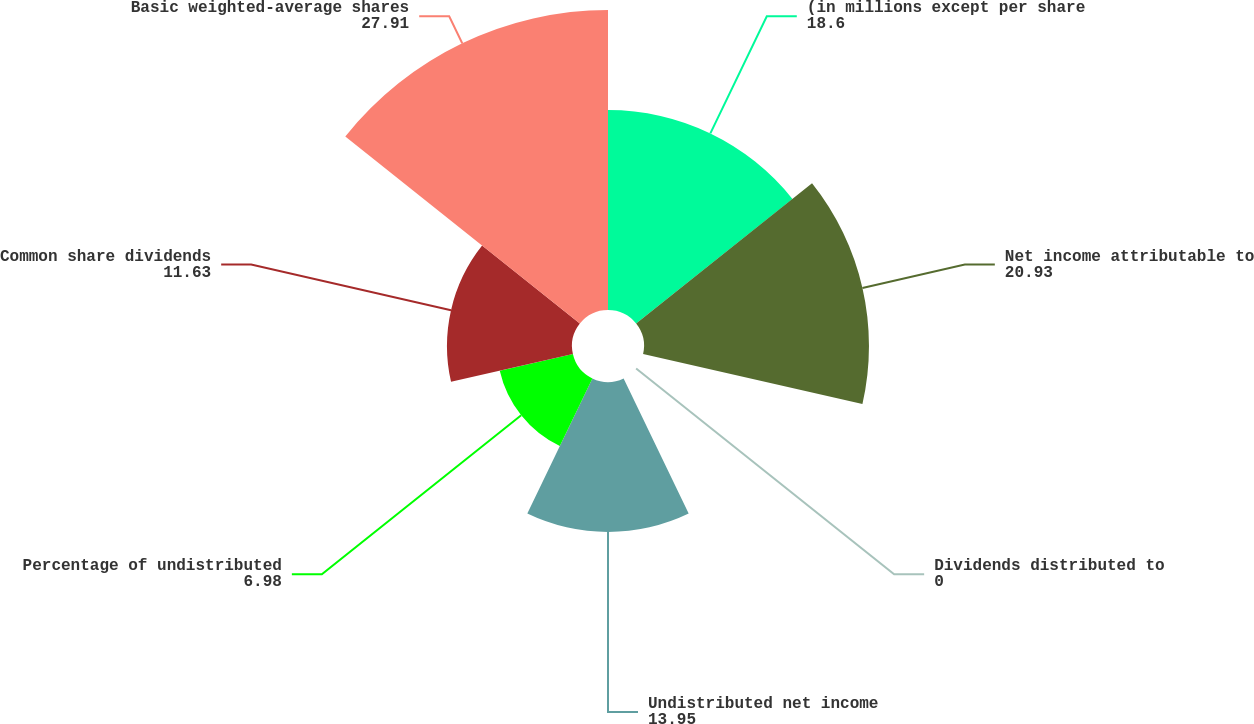<chart> <loc_0><loc_0><loc_500><loc_500><pie_chart><fcel>(in millions except per share<fcel>Net income attributable to<fcel>Dividends distributed to<fcel>Undistributed net income<fcel>Percentage of undistributed<fcel>Common share dividends<fcel>Basic weighted-average shares<nl><fcel>18.6%<fcel>20.93%<fcel>0.0%<fcel>13.95%<fcel>6.98%<fcel>11.63%<fcel>27.91%<nl></chart> 